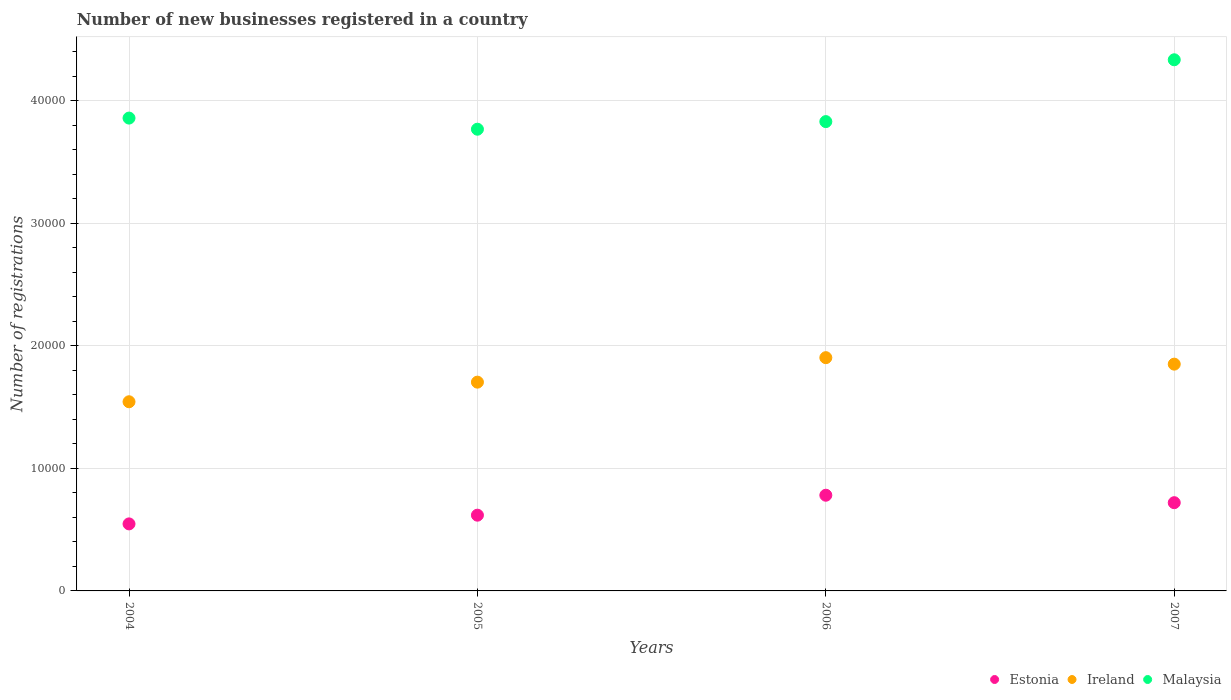How many different coloured dotlines are there?
Your response must be concise. 3. What is the number of new businesses registered in Estonia in 2005?
Your response must be concise. 6180. Across all years, what is the maximum number of new businesses registered in Estonia?
Your response must be concise. 7808. Across all years, what is the minimum number of new businesses registered in Ireland?
Keep it short and to the point. 1.54e+04. In which year was the number of new businesses registered in Malaysia maximum?
Provide a short and direct response. 2007. What is the total number of new businesses registered in Malaysia in the graph?
Make the answer very short. 1.58e+05. What is the difference between the number of new businesses registered in Malaysia in 2004 and that in 2005?
Your answer should be very brief. 908. What is the difference between the number of new businesses registered in Ireland in 2006 and the number of new businesses registered in Malaysia in 2004?
Provide a short and direct response. -1.95e+04. What is the average number of new businesses registered in Ireland per year?
Offer a very short reply. 1.75e+04. In the year 2006, what is the difference between the number of new businesses registered in Estonia and number of new businesses registered in Ireland?
Your answer should be very brief. -1.12e+04. What is the ratio of the number of new businesses registered in Ireland in 2005 to that in 2007?
Keep it short and to the point. 0.92. Is the number of new businesses registered in Estonia in 2006 less than that in 2007?
Keep it short and to the point. No. What is the difference between the highest and the second highest number of new businesses registered in Estonia?
Make the answer very short. 609. What is the difference between the highest and the lowest number of new businesses registered in Estonia?
Provide a short and direct response. 2339. In how many years, is the number of new businesses registered in Ireland greater than the average number of new businesses registered in Ireland taken over all years?
Keep it short and to the point. 2. Is the sum of the number of new businesses registered in Estonia in 2004 and 2006 greater than the maximum number of new businesses registered in Ireland across all years?
Your answer should be compact. No. Is the number of new businesses registered in Ireland strictly greater than the number of new businesses registered in Estonia over the years?
Ensure brevity in your answer.  Yes. Is the number of new businesses registered in Ireland strictly less than the number of new businesses registered in Estonia over the years?
Ensure brevity in your answer.  No. What is the difference between two consecutive major ticks on the Y-axis?
Offer a very short reply. 10000. Are the values on the major ticks of Y-axis written in scientific E-notation?
Give a very brief answer. No. Does the graph contain any zero values?
Make the answer very short. No. Where does the legend appear in the graph?
Offer a very short reply. Bottom right. How are the legend labels stacked?
Provide a succinct answer. Horizontal. What is the title of the graph?
Make the answer very short. Number of new businesses registered in a country. What is the label or title of the Y-axis?
Offer a terse response. Number of registrations. What is the Number of registrations of Estonia in 2004?
Offer a very short reply. 5469. What is the Number of registrations in Ireland in 2004?
Your answer should be very brief. 1.54e+04. What is the Number of registrations of Malaysia in 2004?
Provide a short and direct response. 3.86e+04. What is the Number of registrations of Estonia in 2005?
Offer a terse response. 6180. What is the Number of registrations in Ireland in 2005?
Keep it short and to the point. 1.70e+04. What is the Number of registrations in Malaysia in 2005?
Your answer should be very brief. 3.77e+04. What is the Number of registrations in Estonia in 2006?
Your response must be concise. 7808. What is the Number of registrations of Ireland in 2006?
Provide a succinct answer. 1.90e+04. What is the Number of registrations of Malaysia in 2006?
Your answer should be very brief. 3.83e+04. What is the Number of registrations of Estonia in 2007?
Provide a short and direct response. 7199. What is the Number of registrations of Ireland in 2007?
Your answer should be very brief. 1.85e+04. What is the Number of registrations in Malaysia in 2007?
Provide a succinct answer. 4.33e+04. Across all years, what is the maximum Number of registrations in Estonia?
Give a very brief answer. 7808. Across all years, what is the maximum Number of registrations of Ireland?
Make the answer very short. 1.90e+04. Across all years, what is the maximum Number of registrations of Malaysia?
Ensure brevity in your answer.  4.33e+04. Across all years, what is the minimum Number of registrations in Estonia?
Your response must be concise. 5469. Across all years, what is the minimum Number of registrations of Ireland?
Provide a succinct answer. 1.54e+04. Across all years, what is the minimum Number of registrations of Malaysia?
Make the answer very short. 3.77e+04. What is the total Number of registrations of Estonia in the graph?
Offer a terse response. 2.67e+04. What is the total Number of registrations of Ireland in the graph?
Ensure brevity in your answer.  7.00e+04. What is the total Number of registrations in Malaysia in the graph?
Provide a succinct answer. 1.58e+05. What is the difference between the Number of registrations in Estonia in 2004 and that in 2005?
Provide a short and direct response. -711. What is the difference between the Number of registrations of Ireland in 2004 and that in 2005?
Keep it short and to the point. -1600. What is the difference between the Number of registrations in Malaysia in 2004 and that in 2005?
Your answer should be very brief. 908. What is the difference between the Number of registrations in Estonia in 2004 and that in 2006?
Your answer should be very brief. -2339. What is the difference between the Number of registrations of Ireland in 2004 and that in 2006?
Ensure brevity in your answer.  -3598. What is the difference between the Number of registrations in Malaysia in 2004 and that in 2006?
Give a very brief answer. 287. What is the difference between the Number of registrations of Estonia in 2004 and that in 2007?
Offer a terse response. -1730. What is the difference between the Number of registrations of Ireland in 2004 and that in 2007?
Offer a very short reply. -3069. What is the difference between the Number of registrations of Malaysia in 2004 and that in 2007?
Make the answer very short. -4757. What is the difference between the Number of registrations of Estonia in 2005 and that in 2006?
Offer a very short reply. -1628. What is the difference between the Number of registrations in Ireland in 2005 and that in 2006?
Make the answer very short. -1998. What is the difference between the Number of registrations in Malaysia in 2005 and that in 2006?
Keep it short and to the point. -621. What is the difference between the Number of registrations in Estonia in 2005 and that in 2007?
Provide a short and direct response. -1019. What is the difference between the Number of registrations of Ireland in 2005 and that in 2007?
Your response must be concise. -1469. What is the difference between the Number of registrations of Malaysia in 2005 and that in 2007?
Keep it short and to the point. -5665. What is the difference between the Number of registrations in Estonia in 2006 and that in 2007?
Provide a succinct answer. 609. What is the difference between the Number of registrations of Ireland in 2006 and that in 2007?
Ensure brevity in your answer.  529. What is the difference between the Number of registrations of Malaysia in 2006 and that in 2007?
Offer a very short reply. -5044. What is the difference between the Number of registrations in Estonia in 2004 and the Number of registrations in Ireland in 2005?
Ensure brevity in your answer.  -1.16e+04. What is the difference between the Number of registrations in Estonia in 2004 and the Number of registrations in Malaysia in 2005?
Offer a terse response. -3.22e+04. What is the difference between the Number of registrations of Ireland in 2004 and the Number of registrations of Malaysia in 2005?
Make the answer very short. -2.22e+04. What is the difference between the Number of registrations of Estonia in 2004 and the Number of registrations of Ireland in 2006?
Give a very brief answer. -1.36e+04. What is the difference between the Number of registrations of Estonia in 2004 and the Number of registrations of Malaysia in 2006?
Provide a succinct answer. -3.28e+04. What is the difference between the Number of registrations in Ireland in 2004 and the Number of registrations in Malaysia in 2006?
Give a very brief answer. -2.29e+04. What is the difference between the Number of registrations of Estonia in 2004 and the Number of registrations of Ireland in 2007?
Make the answer very short. -1.30e+04. What is the difference between the Number of registrations in Estonia in 2004 and the Number of registrations in Malaysia in 2007?
Your answer should be compact. -3.79e+04. What is the difference between the Number of registrations in Ireland in 2004 and the Number of registrations in Malaysia in 2007?
Offer a very short reply. -2.79e+04. What is the difference between the Number of registrations in Estonia in 2005 and the Number of registrations in Ireland in 2006?
Offer a terse response. -1.29e+04. What is the difference between the Number of registrations of Estonia in 2005 and the Number of registrations of Malaysia in 2006?
Your answer should be very brief. -3.21e+04. What is the difference between the Number of registrations of Ireland in 2005 and the Number of registrations of Malaysia in 2006?
Your response must be concise. -2.13e+04. What is the difference between the Number of registrations of Estonia in 2005 and the Number of registrations of Ireland in 2007?
Offer a very short reply. -1.23e+04. What is the difference between the Number of registrations in Estonia in 2005 and the Number of registrations in Malaysia in 2007?
Make the answer very short. -3.72e+04. What is the difference between the Number of registrations of Ireland in 2005 and the Number of registrations of Malaysia in 2007?
Keep it short and to the point. -2.63e+04. What is the difference between the Number of registrations of Estonia in 2006 and the Number of registrations of Ireland in 2007?
Give a very brief answer. -1.07e+04. What is the difference between the Number of registrations in Estonia in 2006 and the Number of registrations in Malaysia in 2007?
Provide a succinct answer. -3.55e+04. What is the difference between the Number of registrations in Ireland in 2006 and the Number of registrations in Malaysia in 2007?
Provide a short and direct response. -2.43e+04. What is the average Number of registrations in Estonia per year?
Keep it short and to the point. 6664. What is the average Number of registrations of Ireland per year?
Your answer should be very brief. 1.75e+04. What is the average Number of registrations of Malaysia per year?
Keep it short and to the point. 3.95e+04. In the year 2004, what is the difference between the Number of registrations of Estonia and Number of registrations of Ireland?
Keep it short and to the point. -9965. In the year 2004, what is the difference between the Number of registrations in Estonia and Number of registrations in Malaysia?
Give a very brief answer. -3.31e+04. In the year 2004, what is the difference between the Number of registrations of Ireland and Number of registrations of Malaysia?
Your answer should be compact. -2.31e+04. In the year 2005, what is the difference between the Number of registrations in Estonia and Number of registrations in Ireland?
Your answer should be compact. -1.09e+04. In the year 2005, what is the difference between the Number of registrations in Estonia and Number of registrations in Malaysia?
Your response must be concise. -3.15e+04. In the year 2005, what is the difference between the Number of registrations of Ireland and Number of registrations of Malaysia?
Offer a terse response. -2.06e+04. In the year 2006, what is the difference between the Number of registrations of Estonia and Number of registrations of Ireland?
Give a very brief answer. -1.12e+04. In the year 2006, what is the difference between the Number of registrations in Estonia and Number of registrations in Malaysia?
Your response must be concise. -3.05e+04. In the year 2006, what is the difference between the Number of registrations of Ireland and Number of registrations of Malaysia?
Your answer should be very brief. -1.93e+04. In the year 2007, what is the difference between the Number of registrations of Estonia and Number of registrations of Ireland?
Give a very brief answer. -1.13e+04. In the year 2007, what is the difference between the Number of registrations in Estonia and Number of registrations in Malaysia?
Keep it short and to the point. -3.61e+04. In the year 2007, what is the difference between the Number of registrations in Ireland and Number of registrations in Malaysia?
Provide a short and direct response. -2.48e+04. What is the ratio of the Number of registrations in Estonia in 2004 to that in 2005?
Keep it short and to the point. 0.89. What is the ratio of the Number of registrations of Ireland in 2004 to that in 2005?
Give a very brief answer. 0.91. What is the ratio of the Number of registrations in Malaysia in 2004 to that in 2005?
Make the answer very short. 1.02. What is the ratio of the Number of registrations of Estonia in 2004 to that in 2006?
Ensure brevity in your answer.  0.7. What is the ratio of the Number of registrations in Ireland in 2004 to that in 2006?
Offer a very short reply. 0.81. What is the ratio of the Number of registrations in Malaysia in 2004 to that in 2006?
Provide a succinct answer. 1.01. What is the ratio of the Number of registrations in Estonia in 2004 to that in 2007?
Provide a short and direct response. 0.76. What is the ratio of the Number of registrations of Ireland in 2004 to that in 2007?
Provide a succinct answer. 0.83. What is the ratio of the Number of registrations in Malaysia in 2004 to that in 2007?
Your answer should be compact. 0.89. What is the ratio of the Number of registrations of Estonia in 2005 to that in 2006?
Keep it short and to the point. 0.79. What is the ratio of the Number of registrations in Ireland in 2005 to that in 2006?
Give a very brief answer. 0.9. What is the ratio of the Number of registrations of Malaysia in 2005 to that in 2006?
Provide a succinct answer. 0.98. What is the ratio of the Number of registrations of Estonia in 2005 to that in 2007?
Your answer should be very brief. 0.86. What is the ratio of the Number of registrations of Ireland in 2005 to that in 2007?
Your response must be concise. 0.92. What is the ratio of the Number of registrations of Malaysia in 2005 to that in 2007?
Your response must be concise. 0.87. What is the ratio of the Number of registrations of Estonia in 2006 to that in 2007?
Give a very brief answer. 1.08. What is the ratio of the Number of registrations of Ireland in 2006 to that in 2007?
Your answer should be compact. 1.03. What is the ratio of the Number of registrations in Malaysia in 2006 to that in 2007?
Your response must be concise. 0.88. What is the difference between the highest and the second highest Number of registrations of Estonia?
Give a very brief answer. 609. What is the difference between the highest and the second highest Number of registrations of Ireland?
Your answer should be very brief. 529. What is the difference between the highest and the second highest Number of registrations in Malaysia?
Your answer should be compact. 4757. What is the difference between the highest and the lowest Number of registrations in Estonia?
Offer a very short reply. 2339. What is the difference between the highest and the lowest Number of registrations in Ireland?
Provide a succinct answer. 3598. What is the difference between the highest and the lowest Number of registrations of Malaysia?
Your response must be concise. 5665. 